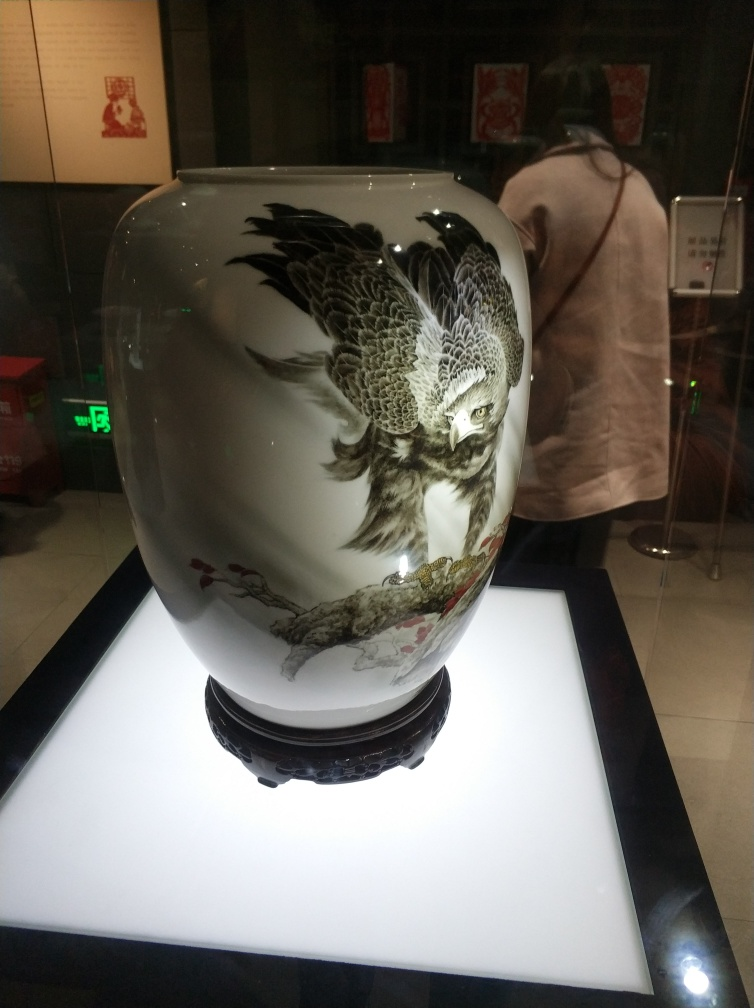What is the sharpness level of this photo?
A. relatively high
B. very high
C. low
D. moderate The photo exhibits a relatively high level of sharpness, as evidenced by the clear details in the artwork on the vase, the intricate line work, and the nuanced shading. Though there is some reflection and ambient light that might slightly affect the perceived sharpness, the overall quality of the image is well-captured, placing it between options A (relatively high) and B (very high). However, considering that the finest details are distinguishable and the noise level is low, a grade slightly above 'A' would be more accurate. 